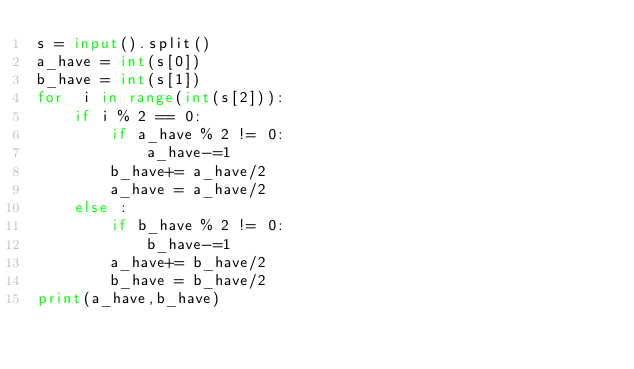Convert code to text. <code><loc_0><loc_0><loc_500><loc_500><_Python_>s = input().split()
a_have = int(s[0])
b_have = int(s[1])
for  i in range(int(s[2])):
    if i % 2 == 0:
        if a_have % 2 != 0:
            a_have-=1
        b_have+= a_have/2
        a_have = a_have/2
    else :
        if b_have % 2 != 0:
            b_have-=1
        a_have+= b_have/2
        b_have = b_have/2
print(a_have,b_have)
</code> 